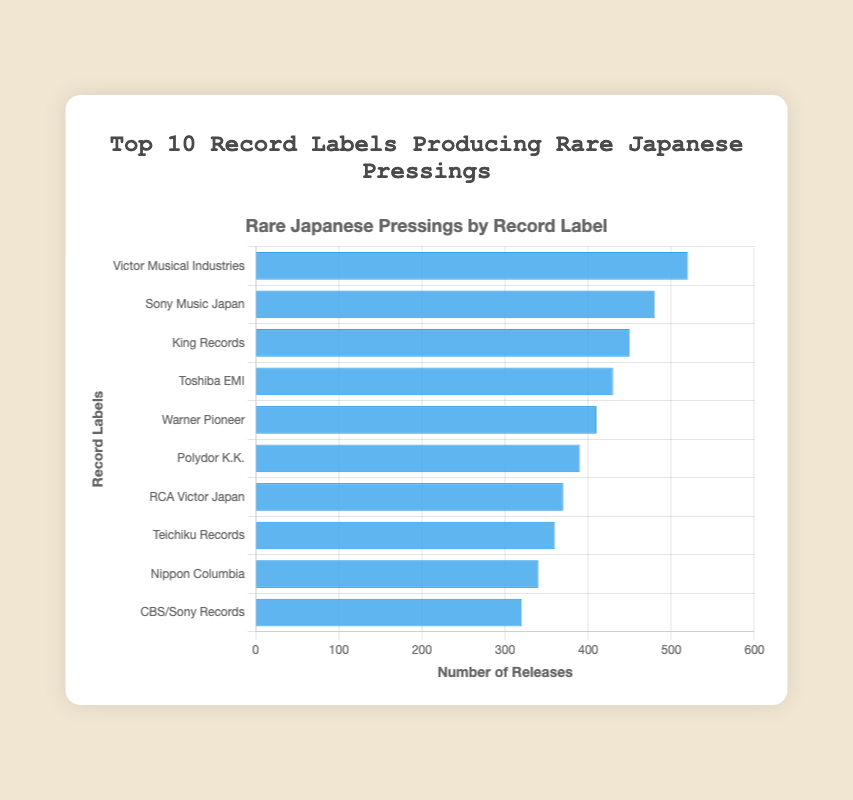What is the most releasing record label in this figure? By looking at the height of the bars or the numbers on the x-axis, it is evident that "Victor Musical Industries" has the highest bar with 520 releases.
Answer: Victor Musical Industries What is the difference in the number of releases between Sony Music Japan and King Records? Sony Music Japan has 480 releases, and King Records has 450 releases. The difference is calculated as 480 - 450 = 30.
Answer: 30 How many total releases are there for the top 3 record labels? The releases for the top 3 labels are Victor Musical Industries (520), Sony Music Japan (480), and King Records (450). The total is 520 + 480 + 450 = 1450.
Answer: 1450 Which record label has the fewest releases? The shortest bar represents CBS/Sony Records which has 320 releases, making it the label with the fewest releases in this chart.
Answer: CBS/Sony Records What is the average number of releases for the 10 record labels? First, sum the number of releases for all labels: 520 + 480 + 450 + 430 + 410 + 390 + 370 + 360 + 340 + 320 = 4070. Then divide by the number of labels: 4070 / 10 = 407.
Answer: 407 Is Warner Pioneer producing more releases than Teichiku Records? Warner Pioneer has 410 releases, while Teichiku Records has 360 releases. 410 is greater than 360, so yes, Warner Pioneer produces more releases.
Answer: Yes What is the range of the number of releases among all record labels? The range is calculated by subtracting the smallest number of releases from the largest. The largest is 520 (Victor Musical Industries) and the smallest is 320 (CBS/Sony Records), so the range is 520 - 320 = 200.
Answer: 200 Which record labels have more than 400 releases? The labels with more than 400 releases are Victor Musical Industries (520), Sony Music Japan (480), King Records (450), Toshiba EMI (430), and Warner Pioneer (410).
Answer: Victor Musical Industries, Sony Music Japan, King Records, Toshiba EMI, Warner Pioneer How many record labels have fewer than 350 releases? By counting the bars that represent fewer than 350 releases, there are two record labels: Nippon Columbia (340) and CBS/Sony Records (320).
Answer: 2 What is the median number of releases among the top 10 record labels? To find the median, first list the number of releases in ascending order: 320, 340, 360, 370, 390, 410, 430, 450, 480, 520. The median is the average of the 5th and 6th values, which are 390 and 410. The median is (390 + 410) / 2 = 400.
Answer: 400 